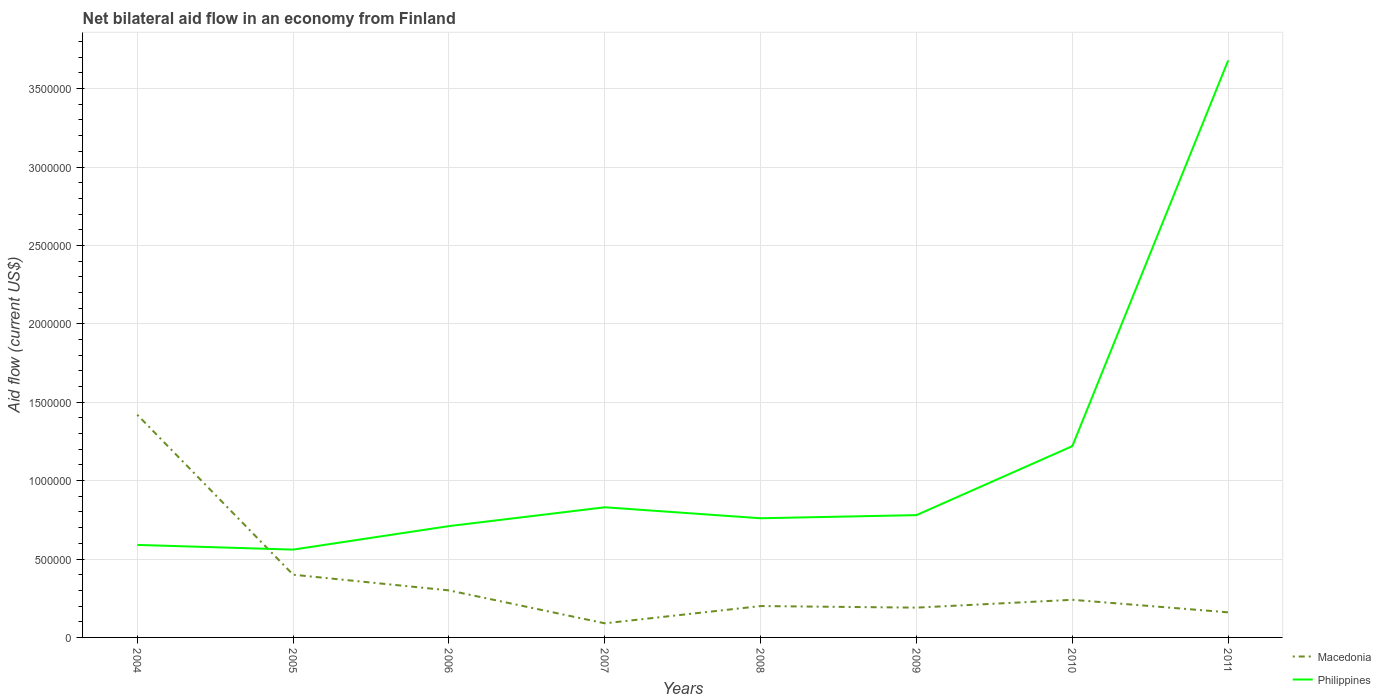What is the total net bilateral aid flow in Philippines in the graph?
Your response must be concise. -1.20e+05. What is the difference between the highest and the second highest net bilateral aid flow in Philippines?
Provide a short and direct response. 3.12e+06. What is the difference between the highest and the lowest net bilateral aid flow in Philippines?
Offer a very short reply. 2. Is the net bilateral aid flow in Macedonia strictly greater than the net bilateral aid flow in Philippines over the years?
Offer a terse response. No. What is the difference between two consecutive major ticks on the Y-axis?
Keep it short and to the point. 5.00e+05. Are the values on the major ticks of Y-axis written in scientific E-notation?
Offer a terse response. No. Does the graph contain any zero values?
Keep it short and to the point. No. How many legend labels are there?
Provide a succinct answer. 2. What is the title of the graph?
Ensure brevity in your answer.  Net bilateral aid flow in an economy from Finland. Does "Mongolia" appear as one of the legend labels in the graph?
Your answer should be very brief. No. What is the label or title of the X-axis?
Give a very brief answer. Years. What is the Aid flow (current US$) of Macedonia in 2004?
Your response must be concise. 1.42e+06. What is the Aid flow (current US$) of Philippines in 2004?
Your response must be concise. 5.90e+05. What is the Aid flow (current US$) in Philippines in 2005?
Offer a terse response. 5.60e+05. What is the Aid flow (current US$) in Philippines in 2006?
Offer a very short reply. 7.10e+05. What is the Aid flow (current US$) in Philippines in 2007?
Provide a short and direct response. 8.30e+05. What is the Aid flow (current US$) in Macedonia in 2008?
Provide a succinct answer. 2.00e+05. What is the Aid flow (current US$) in Philippines in 2008?
Your answer should be compact. 7.60e+05. What is the Aid flow (current US$) in Philippines in 2009?
Offer a terse response. 7.80e+05. What is the Aid flow (current US$) in Macedonia in 2010?
Provide a short and direct response. 2.40e+05. What is the Aid flow (current US$) in Philippines in 2010?
Make the answer very short. 1.22e+06. What is the Aid flow (current US$) of Philippines in 2011?
Your answer should be compact. 3.68e+06. Across all years, what is the maximum Aid flow (current US$) in Macedonia?
Provide a short and direct response. 1.42e+06. Across all years, what is the maximum Aid flow (current US$) in Philippines?
Offer a very short reply. 3.68e+06. Across all years, what is the minimum Aid flow (current US$) in Macedonia?
Make the answer very short. 9.00e+04. Across all years, what is the minimum Aid flow (current US$) in Philippines?
Make the answer very short. 5.60e+05. What is the total Aid flow (current US$) in Philippines in the graph?
Provide a succinct answer. 9.13e+06. What is the difference between the Aid flow (current US$) of Macedonia in 2004 and that in 2005?
Offer a terse response. 1.02e+06. What is the difference between the Aid flow (current US$) in Philippines in 2004 and that in 2005?
Offer a terse response. 3.00e+04. What is the difference between the Aid flow (current US$) of Macedonia in 2004 and that in 2006?
Make the answer very short. 1.12e+06. What is the difference between the Aid flow (current US$) in Philippines in 2004 and that in 2006?
Make the answer very short. -1.20e+05. What is the difference between the Aid flow (current US$) in Macedonia in 2004 and that in 2007?
Offer a terse response. 1.33e+06. What is the difference between the Aid flow (current US$) in Macedonia in 2004 and that in 2008?
Give a very brief answer. 1.22e+06. What is the difference between the Aid flow (current US$) in Macedonia in 2004 and that in 2009?
Provide a succinct answer. 1.23e+06. What is the difference between the Aid flow (current US$) of Macedonia in 2004 and that in 2010?
Offer a terse response. 1.18e+06. What is the difference between the Aid flow (current US$) in Philippines in 2004 and that in 2010?
Give a very brief answer. -6.30e+05. What is the difference between the Aid flow (current US$) of Macedonia in 2004 and that in 2011?
Ensure brevity in your answer.  1.26e+06. What is the difference between the Aid flow (current US$) of Philippines in 2004 and that in 2011?
Give a very brief answer. -3.09e+06. What is the difference between the Aid flow (current US$) of Macedonia in 2005 and that in 2006?
Provide a succinct answer. 1.00e+05. What is the difference between the Aid flow (current US$) in Macedonia in 2005 and that in 2007?
Provide a succinct answer. 3.10e+05. What is the difference between the Aid flow (current US$) in Philippines in 2005 and that in 2007?
Keep it short and to the point. -2.70e+05. What is the difference between the Aid flow (current US$) in Macedonia in 2005 and that in 2008?
Offer a terse response. 2.00e+05. What is the difference between the Aid flow (current US$) of Philippines in 2005 and that in 2008?
Provide a short and direct response. -2.00e+05. What is the difference between the Aid flow (current US$) in Philippines in 2005 and that in 2009?
Your answer should be compact. -2.20e+05. What is the difference between the Aid flow (current US$) in Philippines in 2005 and that in 2010?
Your response must be concise. -6.60e+05. What is the difference between the Aid flow (current US$) of Macedonia in 2005 and that in 2011?
Make the answer very short. 2.40e+05. What is the difference between the Aid flow (current US$) of Philippines in 2005 and that in 2011?
Provide a succinct answer. -3.12e+06. What is the difference between the Aid flow (current US$) of Macedonia in 2006 and that in 2008?
Your response must be concise. 1.00e+05. What is the difference between the Aid flow (current US$) of Macedonia in 2006 and that in 2009?
Give a very brief answer. 1.10e+05. What is the difference between the Aid flow (current US$) of Philippines in 2006 and that in 2009?
Provide a succinct answer. -7.00e+04. What is the difference between the Aid flow (current US$) of Macedonia in 2006 and that in 2010?
Your response must be concise. 6.00e+04. What is the difference between the Aid flow (current US$) of Philippines in 2006 and that in 2010?
Your response must be concise. -5.10e+05. What is the difference between the Aid flow (current US$) of Macedonia in 2006 and that in 2011?
Your response must be concise. 1.40e+05. What is the difference between the Aid flow (current US$) of Philippines in 2006 and that in 2011?
Offer a terse response. -2.97e+06. What is the difference between the Aid flow (current US$) of Philippines in 2007 and that in 2008?
Your response must be concise. 7.00e+04. What is the difference between the Aid flow (current US$) of Macedonia in 2007 and that in 2010?
Provide a succinct answer. -1.50e+05. What is the difference between the Aid flow (current US$) in Philippines in 2007 and that in 2010?
Make the answer very short. -3.90e+05. What is the difference between the Aid flow (current US$) in Macedonia in 2007 and that in 2011?
Give a very brief answer. -7.00e+04. What is the difference between the Aid flow (current US$) in Philippines in 2007 and that in 2011?
Provide a succinct answer. -2.85e+06. What is the difference between the Aid flow (current US$) in Macedonia in 2008 and that in 2009?
Ensure brevity in your answer.  10000. What is the difference between the Aid flow (current US$) of Philippines in 2008 and that in 2009?
Offer a terse response. -2.00e+04. What is the difference between the Aid flow (current US$) of Macedonia in 2008 and that in 2010?
Give a very brief answer. -4.00e+04. What is the difference between the Aid flow (current US$) in Philippines in 2008 and that in 2010?
Provide a short and direct response. -4.60e+05. What is the difference between the Aid flow (current US$) in Philippines in 2008 and that in 2011?
Offer a terse response. -2.92e+06. What is the difference between the Aid flow (current US$) of Macedonia in 2009 and that in 2010?
Offer a very short reply. -5.00e+04. What is the difference between the Aid flow (current US$) of Philippines in 2009 and that in 2010?
Make the answer very short. -4.40e+05. What is the difference between the Aid flow (current US$) in Macedonia in 2009 and that in 2011?
Make the answer very short. 3.00e+04. What is the difference between the Aid flow (current US$) in Philippines in 2009 and that in 2011?
Provide a succinct answer. -2.90e+06. What is the difference between the Aid flow (current US$) of Macedonia in 2010 and that in 2011?
Offer a terse response. 8.00e+04. What is the difference between the Aid flow (current US$) in Philippines in 2010 and that in 2011?
Keep it short and to the point. -2.46e+06. What is the difference between the Aid flow (current US$) in Macedonia in 2004 and the Aid flow (current US$) in Philippines in 2005?
Your answer should be very brief. 8.60e+05. What is the difference between the Aid flow (current US$) in Macedonia in 2004 and the Aid flow (current US$) in Philippines in 2006?
Your response must be concise. 7.10e+05. What is the difference between the Aid flow (current US$) of Macedonia in 2004 and the Aid flow (current US$) of Philippines in 2007?
Give a very brief answer. 5.90e+05. What is the difference between the Aid flow (current US$) in Macedonia in 2004 and the Aid flow (current US$) in Philippines in 2009?
Your answer should be very brief. 6.40e+05. What is the difference between the Aid flow (current US$) of Macedonia in 2004 and the Aid flow (current US$) of Philippines in 2011?
Offer a very short reply. -2.26e+06. What is the difference between the Aid flow (current US$) of Macedonia in 2005 and the Aid flow (current US$) of Philippines in 2006?
Offer a very short reply. -3.10e+05. What is the difference between the Aid flow (current US$) in Macedonia in 2005 and the Aid flow (current US$) in Philippines in 2007?
Keep it short and to the point. -4.30e+05. What is the difference between the Aid flow (current US$) of Macedonia in 2005 and the Aid flow (current US$) of Philippines in 2008?
Provide a short and direct response. -3.60e+05. What is the difference between the Aid flow (current US$) of Macedonia in 2005 and the Aid flow (current US$) of Philippines in 2009?
Your answer should be very brief. -3.80e+05. What is the difference between the Aid flow (current US$) in Macedonia in 2005 and the Aid flow (current US$) in Philippines in 2010?
Give a very brief answer. -8.20e+05. What is the difference between the Aid flow (current US$) in Macedonia in 2005 and the Aid flow (current US$) in Philippines in 2011?
Provide a short and direct response. -3.28e+06. What is the difference between the Aid flow (current US$) of Macedonia in 2006 and the Aid flow (current US$) of Philippines in 2007?
Give a very brief answer. -5.30e+05. What is the difference between the Aid flow (current US$) in Macedonia in 2006 and the Aid flow (current US$) in Philippines in 2008?
Offer a terse response. -4.60e+05. What is the difference between the Aid flow (current US$) in Macedonia in 2006 and the Aid flow (current US$) in Philippines in 2009?
Keep it short and to the point. -4.80e+05. What is the difference between the Aid flow (current US$) in Macedonia in 2006 and the Aid flow (current US$) in Philippines in 2010?
Your response must be concise. -9.20e+05. What is the difference between the Aid flow (current US$) in Macedonia in 2006 and the Aid flow (current US$) in Philippines in 2011?
Offer a terse response. -3.38e+06. What is the difference between the Aid flow (current US$) of Macedonia in 2007 and the Aid flow (current US$) of Philippines in 2008?
Your answer should be very brief. -6.70e+05. What is the difference between the Aid flow (current US$) of Macedonia in 2007 and the Aid flow (current US$) of Philippines in 2009?
Provide a succinct answer. -6.90e+05. What is the difference between the Aid flow (current US$) of Macedonia in 2007 and the Aid flow (current US$) of Philippines in 2010?
Provide a succinct answer. -1.13e+06. What is the difference between the Aid flow (current US$) in Macedonia in 2007 and the Aid flow (current US$) in Philippines in 2011?
Offer a very short reply. -3.59e+06. What is the difference between the Aid flow (current US$) of Macedonia in 2008 and the Aid flow (current US$) of Philippines in 2009?
Provide a succinct answer. -5.80e+05. What is the difference between the Aid flow (current US$) of Macedonia in 2008 and the Aid flow (current US$) of Philippines in 2010?
Provide a succinct answer. -1.02e+06. What is the difference between the Aid flow (current US$) in Macedonia in 2008 and the Aid flow (current US$) in Philippines in 2011?
Offer a very short reply. -3.48e+06. What is the difference between the Aid flow (current US$) in Macedonia in 2009 and the Aid flow (current US$) in Philippines in 2010?
Offer a very short reply. -1.03e+06. What is the difference between the Aid flow (current US$) of Macedonia in 2009 and the Aid flow (current US$) of Philippines in 2011?
Keep it short and to the point. -3.49e+06. What is the difference between the Aid flow (current US$) in Macedonia in 2010 and the Aid flow (current US$) in Philippines in 2011?
Offer a very short reply. -3.44e+06. What is the average Aid flow (current US$) of Macedonia per year?
Offer a very short reply. 3.75e+05. What is the average Aid flow (current US$) of Philippines per year?
Make the answer very short. 1.14e+06. In the year 2004, what is the difference between the Aid flow (current US$) of Macedonia and Aid flow (current US$) of Philippines?
Your answer should be compact. 8.30e+05. In the year 2005, what is the difference between the Aid flow (current US$) of Macedonia and Aid flow (current US$) of Philippines?
Your response must be concise. -1.60e+05. In the year 2006, what is the difference between the Aid flow (current US$) of Macedonia and Aid flow (current US$) of Philippines?
Your answer should be compact. -4.10e+05. In the year 2007, what is the difference between the Aid flow (current US$) of Macedonia and Aid flow (current US$) of Philippines?
Provide a short and direct response. -7.40e+05. In the year 2008, what is the difference between the Aid flow (current US$) of Macedonia and Aid flow (current US$) of Philippines?
Provide a short and direct response. -5.60e+05. In the year 2009, what is the difference between the Aid flow (current US$) in Macedonia and Aid flow (current US$) in Philippines?
Make the answer very short. -5.90e+05. In the year 2010, what is the difference between the Aid flow (current US$) in Macedonia and Aid flow (current US$) in Philippines?
Offer a very short reply. -9.80e+05. In the year 2011, what is the difference between the Aid flow (current US$) of Macedonia and Aid flow (current US$) of Philippines?
Your answer should be very brief. -3.52e+06. What is the ratio of the Aid flow (current US$) in Macedonia in 2004 to that in 2005?
Offer a terse response. 3.55. What is the ratio of the Aid flow (current US$) of Philippines in 2004 to that in 2005?
Offer a terse response. 1.05. What is the ratio of the Aid flow (current US$) of Macedonia in 2004 to that in 2006?
Ensure brevity in your answer.  4.73. What is the ratio of the Aid flow (current US$) in Philippines in 2004 to that in 2006?
Your answer should be compact. 0.83. What is the ratio of the Aid flow (current US$) in Macedonia in 2004 to that in 2007?
Your answer should be compact. 15.78. What is the ratio of the Aid flow (current US$) of Philippines in 2004 to that in 2007?
Your answer should be very brief. 0.71. What is the ratio of the Aid flow (current US$) in Macedonia in 2004 to that in 2008?
Offer a very short reply. 7.1. What is the ratio of the Aid flow (current US$) in Philippines in 2004 to that in 2008?
Offer a very short reply. 0.78. What is the ratio of the Aid flow (current US$) in Macedonia in 2004 to that in 2009?
Your response must be concise. 7.47. What is the ratio of the Aid flow (current US$) of Philippines in 2004 to that in 2009?
Provide a succinct answer. 0.76. What is the ratio of the Aid flow (current US$) of Macedonia in 2004 to that in 2010?
Give a very brief answer. 5.92. What is the ratio of the Aid flow (current US$) in Philippines in 2004 to that in 2010?
Provide a short and direct response. 0.48. What is the ratio of the Aid flow (current US$) in Macedonia in 2004 to that in 2011?
Ensure brevity in your answer.  8.88. What is the ratio of the Aid flow (current US$) of Philippines in 2004 to that in 2011?
Make the answer very short. 0.16. What is the ratio of the Aid flow (current US$) of Macedonia in 2005 to that in 2006?
Make the answer very short. 1.33. What is the ratio of the Aid flow (current US$) in Philippines in 2005 to that in 2006?
Your response must be concise. 0.79. What is the ratio of the Aid flow (current US$) of Macedonia in 2005 to that in 2007?
Make the answer very short. 4.44. What is the ratio of the Aid flow (current US$) in Philippines in 2005 to that in 2007?
Your response must be concise. 0.67. What is the ratio of the Aid flow (current US$) in Philippines in 2005 to that in 2008?
Provide a succinct answer. 0.74. What is the ratio of the Aid flow (current US$) in Macedonia in 2005 to that in 2009?
Your answer should be compact. 2.11. What is the ratio of the Aid flow (current US$) of Philippines in 2005 to that in 2009?
Offer a very short reply. 0.72. What is the ratio of the Aid flow (current US$) in Philippines in 2005 to that in 2010?
Offer a very short reply. 0.46. What is the ratio of the Aid flow (current US$) in Philippines in 2005 to that in 2011?
Provide a short and direct response. 0.15. What is the ratio of the Aid flow (current US$) in Philippines in 2006 to that in 2007?
Keep it short and to the point. 0.86. What is the ratio of the Aid flow (current US$) in Macedonia in 2006 to that in 2008?
Give a very brief answer. 1.5. What is the ratio of the Aid flow (current US$) of Philippines in 2006 to that in 2008?
Your response must be concise. 0.93. What is the ratio of the Aid flow (current US$) in Macedonia in 2006 to that in 2009?
Provide a succinct answer. 1.58. What is the ratio of the Aid flow (current US$) in Philippines in 2006 to that in 2009?
Your answer should be very brief. 0.91. What is the ratio of the Aid flow (current US$) in Macedonia in 2006 to that in 2010?
Ensure brevity in your answer.  1.25. What is the ratio of the Aid flow (current US$) of Philippines in 2006 to that in 2010?
Keep it short and to the point. 0.58. What is the ratio of the Aid flow (current US$) in Macedonia in 2006 to that in 2011?
Give a very brief answer. 1.88. What is the ratio of the Aid flow (current US$) in Philippines in 2006 to that in 2011?
Make the answer very short. 0.19. What is the ratio of the Aid flow (current US$) in Macedonia in 2007 to that in 2008?
Provide a short and direct response. 0.45. What is the ratio of the Aid flow (current US$) in Philippines in 2007 to that in 2008?
Make the answer very short. 1.09. What is the ratio of the Aid flow (current US$) in Macedonia in 2007 to that in 2009?
Ensure brevity in your answer.  0.47. What is the ratio of the Aid flow (current US$) in Philippines in 2007 to that in 2009?
Your answer should be compact. 1.06. What is the ratio of the Aid flow (current US$) in Macedonia in 2007 to that in 2010?
Provide a short and direct response. 0.38. What is the ratio of the Aid flow (current US$) in Philippines in 2007 to that in 2010?
Offer a very short reply. 0.68. What is the ratio of the Aid flow (current US$) in Macedonia in 2007 to that in 2011?
Offer a very short reply. 0.56. What is the ratio of the Aid flow (current US$) of Philippines in 2007 to that in 2011?
Your answer should be very brief. 0.23. What is the ratio of the Aid flow (current US$) in Macedonia in 2008 to that in 2009?
Provide a succinct answer. 1.05. What is the ratio of the Aid flow (current US$) in Philippines in 2008 to that in 2009?
Give a very brief answer. 0.97. What is the ratio of the Aid flow (current US$) in Philippines in 2008 to that in 2010?
Your response must be concise. 0.62. What is the ratio of the Aid flow (current US$) of Philippines in 2008 to that in 2011?
Your response must be concise. 0.21. What is the ratio of the Aid flow (current US$) of Macedonia in 2009 to that in 2010?
Keep it short and to the point. 0.79. What is the ratio of the Aid flow (current US$) in Philippines in 2009 to that in 2010?
Provide a short and direct response. 0.64. What is the ratio of the Aid flow (current US$) in Macedonia in 2009 to that in 2011?
Your answer should be compact. 1.19. What is the ratio of the Aid flow (current US$) of Philippines in 2009 to that in 2011?
Your answer should be very brief. 0.21. What is the ratio of the Aid flow (current US$) in Philippines in 2010 to that in 2011?
Make the answer very short. 0.33. What is the difference between the highest and the second highest Aid flow (current US$) in Macedonia?
Ensure brevity in your answer.  1.02e+06. What is the difference between the highest and the second highest Aid flow (current US$) of Philippines?
Provide a short and direct response. 2.46e+06. What is the difference between the highest and the lowest Aid flow (current US$) of Macedonia?
Your answer should be very brief. 1.33e+06. What is the difference between the highest and the lowest Aid flow (current US$) in Philippines?
Offer a terse response. 3.12e+06. 